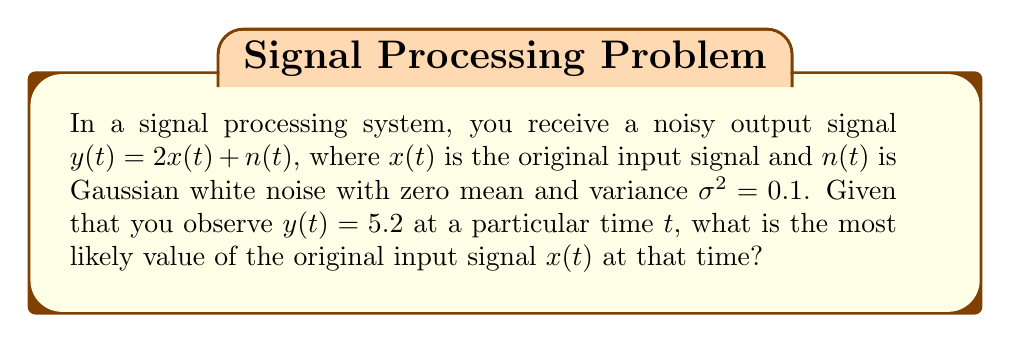Can you answer this question? To determine the most likely value of the original input signal $x(t)$, we can use the Maximum Likelihood Estimation (MLE) method:

1. The relationship between the signals is given by:
   $y(t) = 2x(t) + n(t)$

2. We know that $n(t)$ is Gaussian white noise with zero mean and variance $\sigma^2 = 0.1$

3. The likelihood function for this model is:
   $$L(x) = \frac{1}{\sqrt{2\pi\sigma^2}} \exp\left(-\frac{(y - 2x)^2}{2\sigma^2}\right)$$

4. To find the maximum likelihood estimate, we need to maximize $L(x)$ or, equivalently, minimize the negative log-likelihood:
   $$-\log L(x) = \frac{1}{2}\log(2\pi\sigma^2) + \frac{(y - 2x)^2}{2\sigma^2}$$

5. Differentiate with respect to $x$ and set to zero:
   $$\frac{\partial(-\log L(x))}{\partial x} = -\frac{2(y - 2x)}{2\sigma^2} = 0$$

6. Solve for $x$:
   $$-2(y - 2x) = 0$$
   $$y - 2x = 0$$
   $$2x = y$$
   $$x = \frac{y}{2}$$

7. Given $y(t) = 5.2$, we can calculate $x(t)$:
   $$x(t) = \frac{5.2}{2} = 2.6$$

Therefore, the most likely value of the original input signal $x(t)$ at the given time is 2.6.
Answer: 2.6 